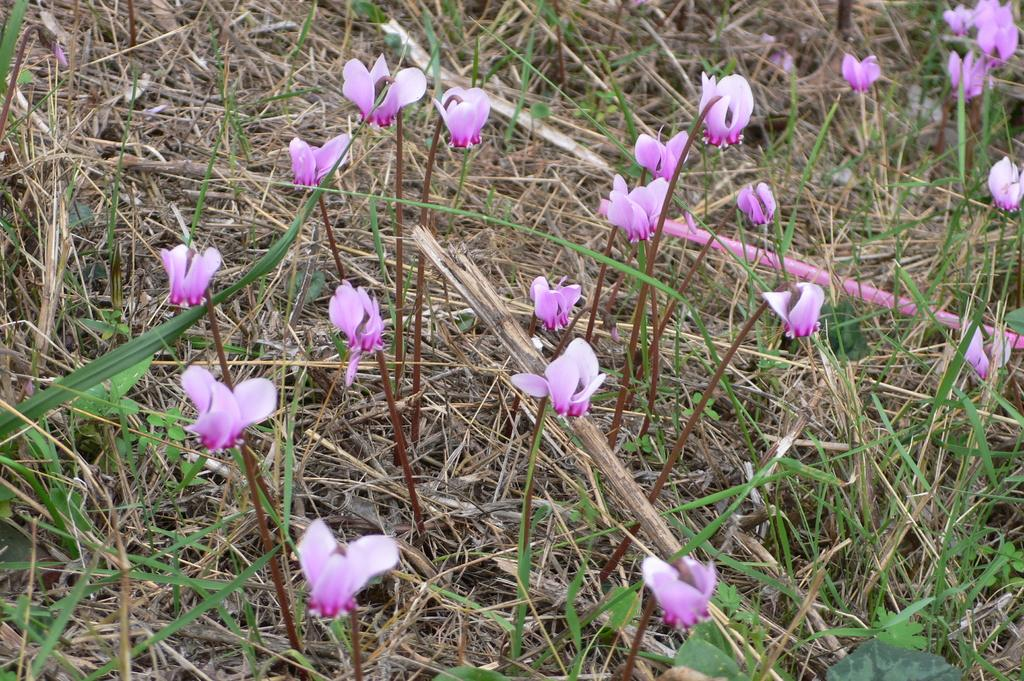What color are the flowers on the plants in the image? The flowers on the plants are pink. What type of vegetation is present at the bottom of the image? There is green grass at the bottom of the image. Can you describe the condition of the grass in the image? There is dried grass in the image. What is the main subject of the image? The main subject of the image is plants. What type of notebook is being used by the flowers in the image? There is no notebook present in the image; it features plants with pink flowers and green and dried grass. 